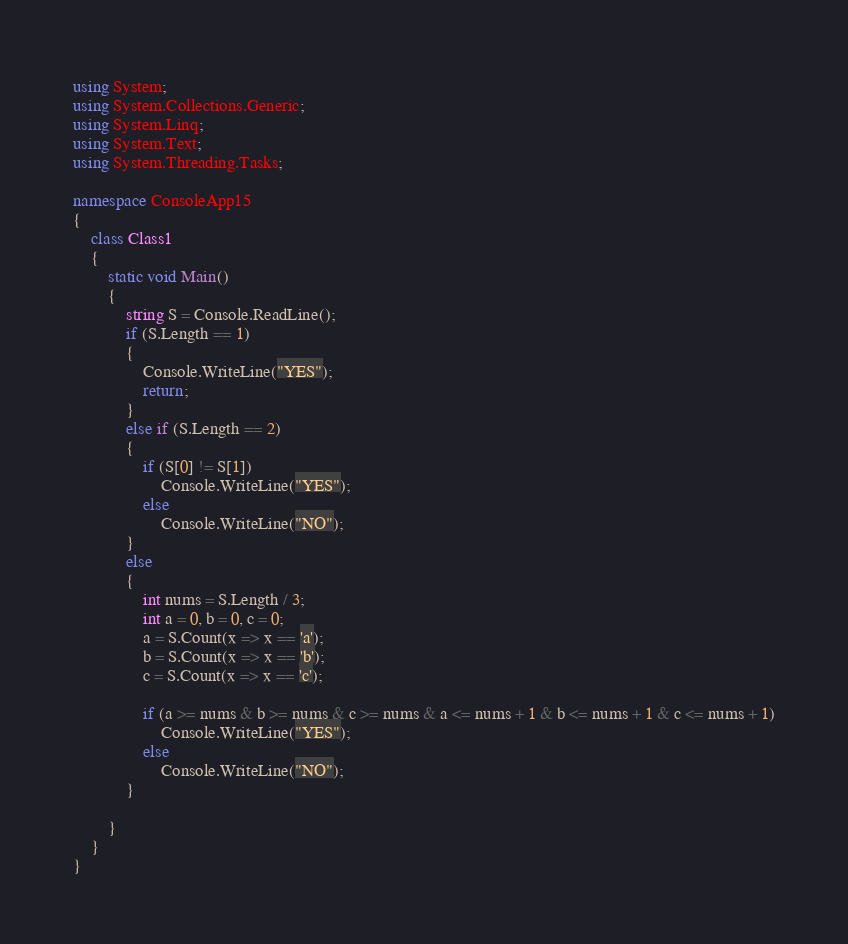Convert code to text. <code><loc_0><loc_0><loc_500><loc_500><_C#_>using System;
using System.Collections.Generic;
using System.Linq;
using System.Text;
using System.Threading.Tasks;

namespace ConsoleApp15
{
    class Class1
    {
        static void Main()
        {
            string S = Console.ReadLine();
            if (S.Length == 1)
            {
                Console.WriteLine("YES");
                return;
            }
            else if (S.Length == 2)
            {
                if (S[0] != S[1])
                    Console.WriteLine("YES");
                else
                    Console.WriteLine("NO");
            }
            else
            {
                int nums = S.Length / 3;
                int a = 0, b = 0, c = 0;
                a = S.Count(x => x == 'a');
                b = S.Count(x => x == 'b');
                c = S.Count(x => x == 'c');

                if (a >= nums & b >= nums & c >= nums & a <= nums + 1 & b <= nums + 1 & c <= nums + 1)
                    Console.WriteLine("YES");
                else
                    Console.WriteLine("NO");
            }
            
        }
    }
}
</code> 